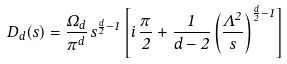<formula> <loc_0><loc_0><loc_500><loc_500>D _ { d } ( s ) = \frac { \Omega _ { d } } { \pi ^ { d } } \, s ^ { \frac { d } { 2 } - 1 } \left [ i \, \frac { \pi } { 2 } + \frac { 1 } { d - 2 } \left ( \frac { \Lambda ^ { 2 } } { s } \right ) ^ { \frac { d } { 2 } - 1 } \right ]</formula> 